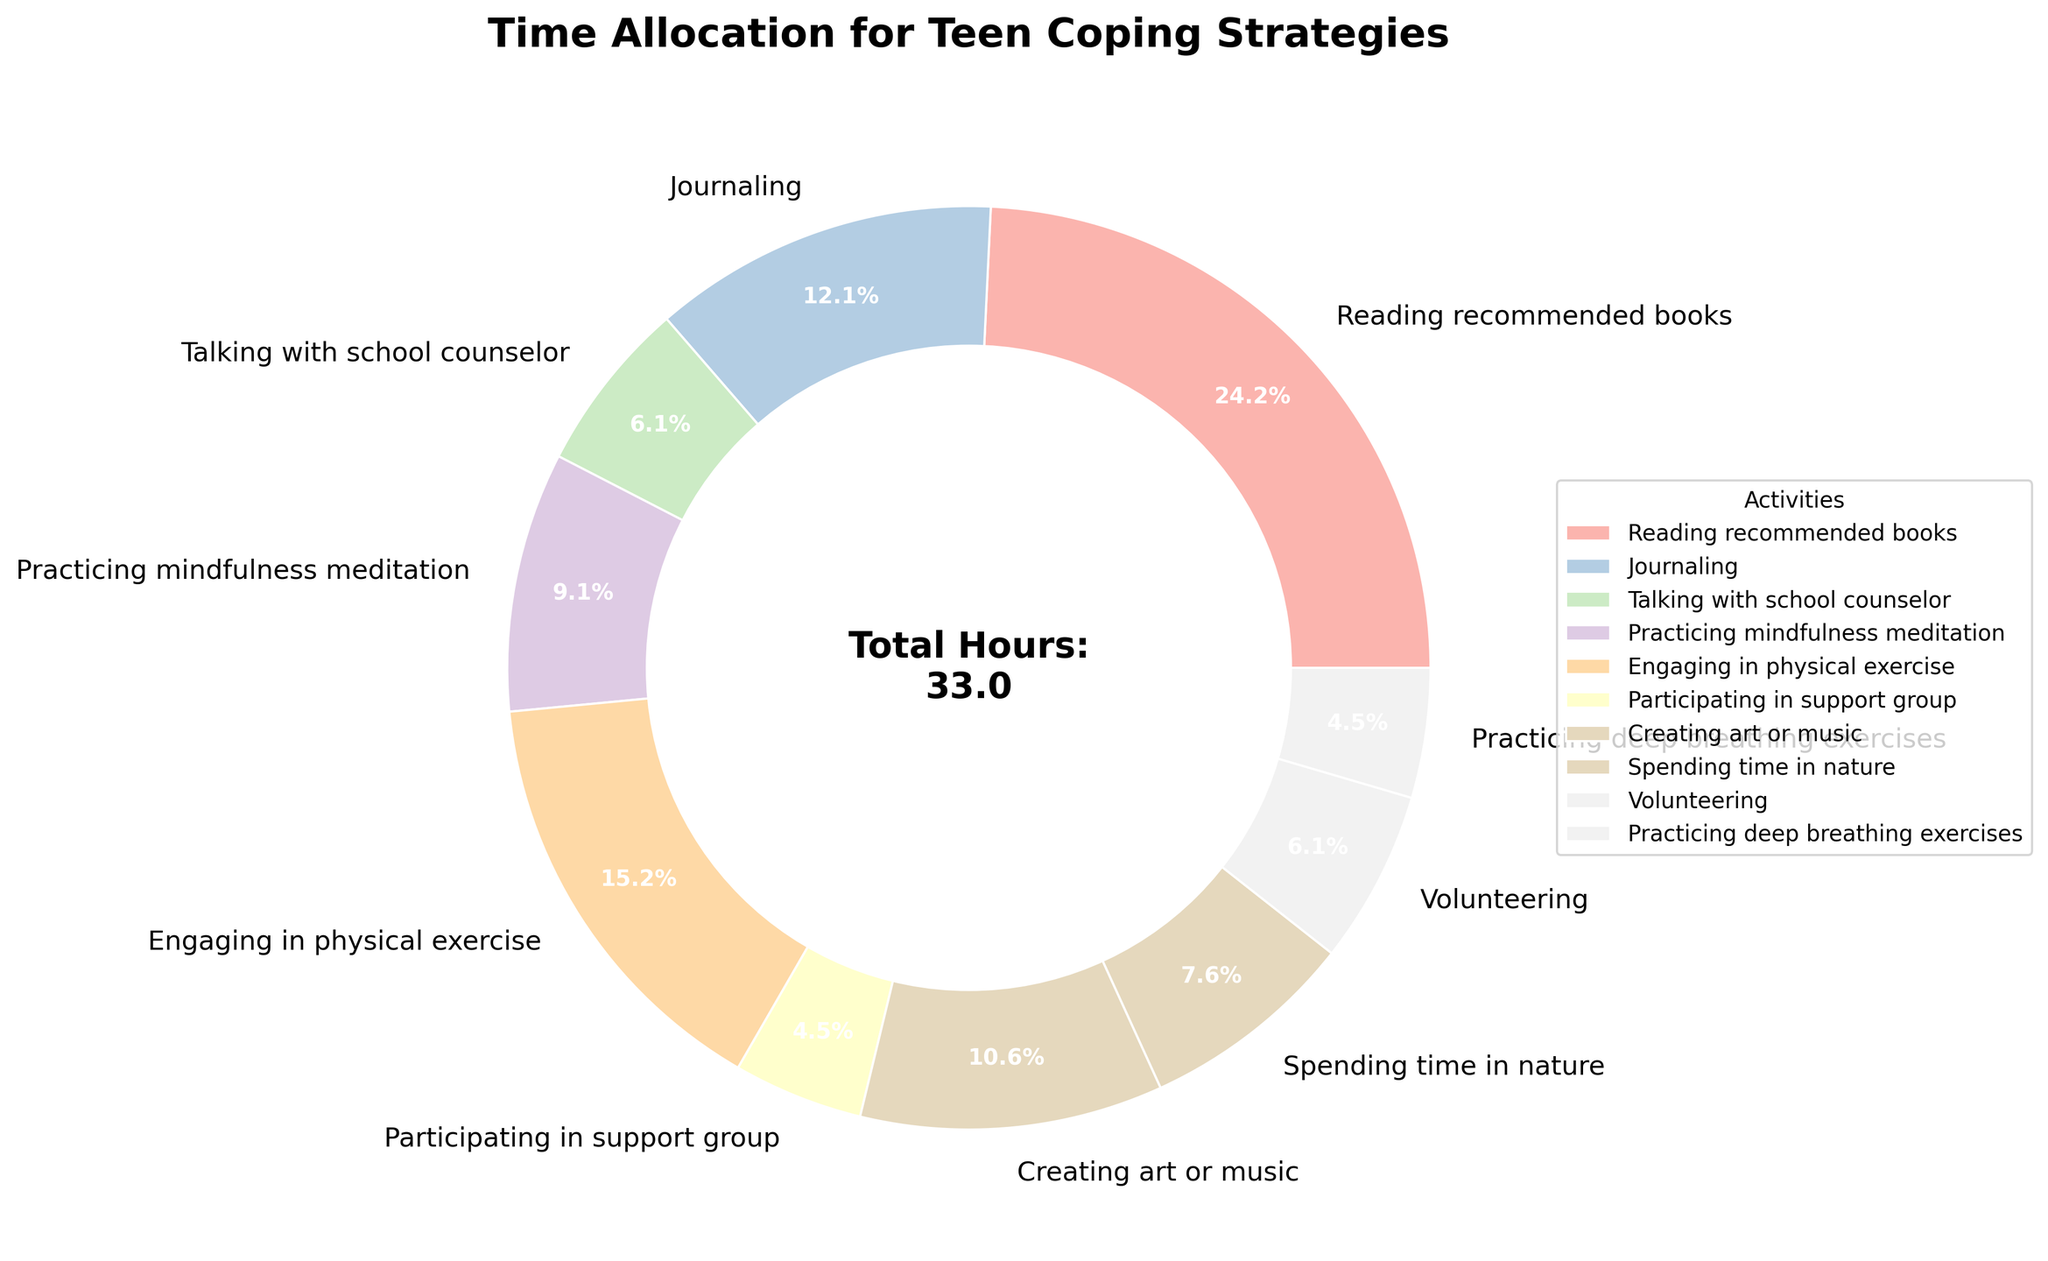Which activity do teens spend the most time on? The activity with the largest percentage on the pie chart represents the activity where teens spend the most time. "Reading recommended books" occupies the largest segment in the pie chart.
Answer: Reading recommended books Which activity do teens spend the least time on? The activity with the smallest percentage on the pie chart represents the activity where teens spend the least time. "Participating in support group" occupies the smallest segment in the pie chart.
Answer: Participating in support group How many total hours per week are spent on "Talking with school counselor" and "Volunteering"? Find the segments labeled "Talking with school counselor" and "Volunteering" on the pie chart, note their hours (2 and 2 respectively), and sum them up. 2 + 2 = 4 hours.
Answer: 4 hours Which activity is more popular: "Engaging in physical exercise" or "Creating art or music"? Compare the segments labeled "Engaging in physical exercise" and "Creating art or music" in the pie chart. The former is 5 hours while the latter is 3.5 hours.
Answer: Engaging in physical exercise What percentage of the total time is spent on "Spending time in nature" and "Practicing deep breathing exercises" combined? Find the segments labeled "Spending time in nature" (2.5 hours) and "Practicing deep breathing exercises" (1.5 hours), sum them up (2.5 + 1.5 = 4), and then divide by the total hours (33). Multiply by 100 to get the percentage: (4 / 33) * 100 ≈ 12.1%.
Answer: About 12.1% How does the time spent on "Journaling" compare to "Practicing mindfulness meditation"? Find the segments for "Journaling" and "Practicing mindfulness meditation". Journaling takes 4 hours, while mindfulness meditation takes 3 hours. Journaling has more hours.
Answer: Journaling What fraction of the total time is dedicated to "Creating art or music"? "Creating art or music" takes 3.5 hours. The total time is 33 hours. The fraction is therefore 3.5 / 33.
Answer: 3.5/33 Is "Volunteering" time greater than "Spending time in nature"? Compare the segments: "Volunteering" has 2 hours, "Spending time in nature" has 2.5 hours. Volunteering has less time.
Answer: No What is the sum of hours spent on activities related to mindfulness, specifically "Practicing mindfulness meditation" and "Practicing deep breathing exercises"? Find the hours for "Practicing mindfulness meditation" (3) and "Practicing deep breathing exercises" (1.5), then add them: 3 + 1.5 = 4.5 hours.
Answer: 4.5 hours How is the time spent on "Practicing mindfulness meditation" and "Volunteering" similar? Both segments are separated and unique in the pie chart, but you can look at their respective hours: "Practicing mindfulness meditation" (3) and "Volunteering" (2). They are close in values.
Answer: They are close in hours 